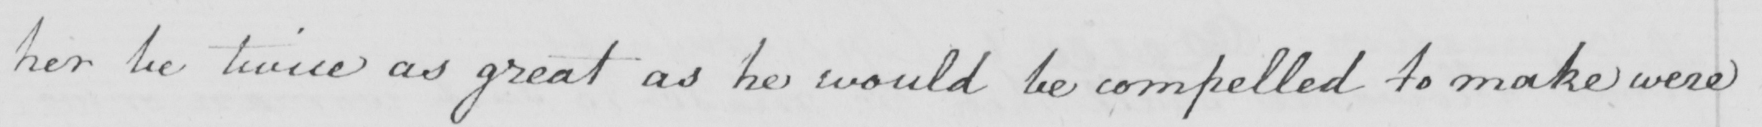Transcribe the text shown in this historical manuscript line. her be twice as great as he would be compelled to make were 